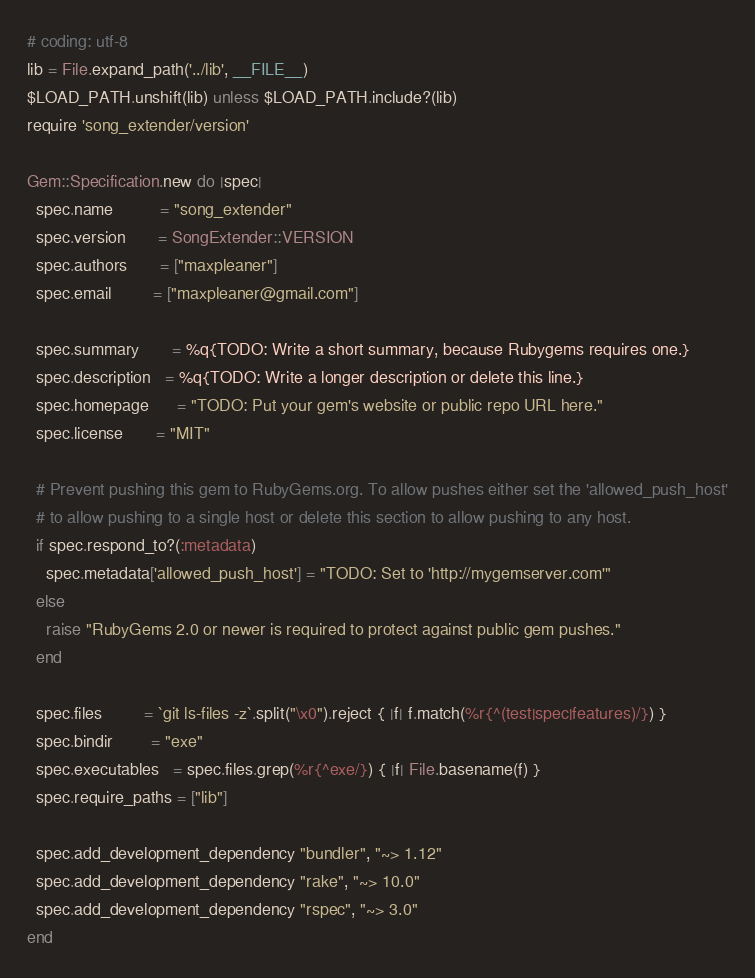Convert code to text. <code><loc_0><loc_0><loc_500><loc_500><_Ruby_># coding: utf-8
lib = File.expand_path('../lib', __FILE__)
$LOAD_PATH.unshift(lib) unless $LOAD_PATH.include?(lib)
require 'song_extender/version'

Gem::Specification.new do |spec|
  spec.name          = "song_extender"
  spec.version       = SongExtender::VERSION
  spec.authors       = ["maxpleaner"]
  spec.email         = ["maxpleaner@gmail.com"]

  spec.summary       = %q{TODO: Write a short summary, because Rubygems requires one.}
  spec.description   = %q{TODO: Write a longer description or delete this line.}
  spec.homepage      = "TODO: Put your gem's website or public repo URL here."
  spec.license       = "MIT"

  # Prevent pushing this gem to RubyGems.org. To allow pushes either set the 'allowed_push_host'
  # to allow pushing to a single host or delete this section to allow pushing to any host.
  if spec.respond_to?(:metadata)
    spec.metadata['allowed_push_host'] = "TODO: Set to 'http://mygemserver.com'"
  else
    raise "RubyGems 2.0 or newer is required to protect against public gem pushes."
  end

  spec.files         = `git ls-files -z`.split("\x0").reject { |f| f.match(%r{^(test|spec|features)/}) }
  spec.bindir        = "exe"
  spec.executables   = spec.files.grep(%r{^exe/}) { |f| File.basename(f) }
  spec.require_paths = ["lib"]

  spec.add_development_dependency "bundler", "~> 1.12"
  spec.add_development_dependency "rake", "~> 10.0"
  spec.add_development_dependency "rspec", "~> 3.0"
end
</code> 